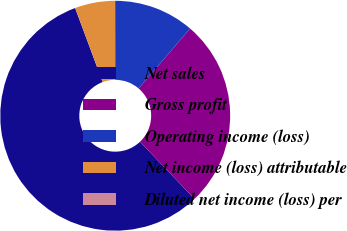Convert chart. <chart><loc_0><loc_0><loc_500><loc_500><pie_chart><fcel>Net sales<fcel>Gross profit<fcel>Operating income (loss)<fcel>Net income (loss) attributable<fcel>Diluted net income (loss) per<nl><fcel>56.44%<fcel>26.6%<fcel>11.3%<fcel>5.65%<fcel>0.01%<nl></chart> 